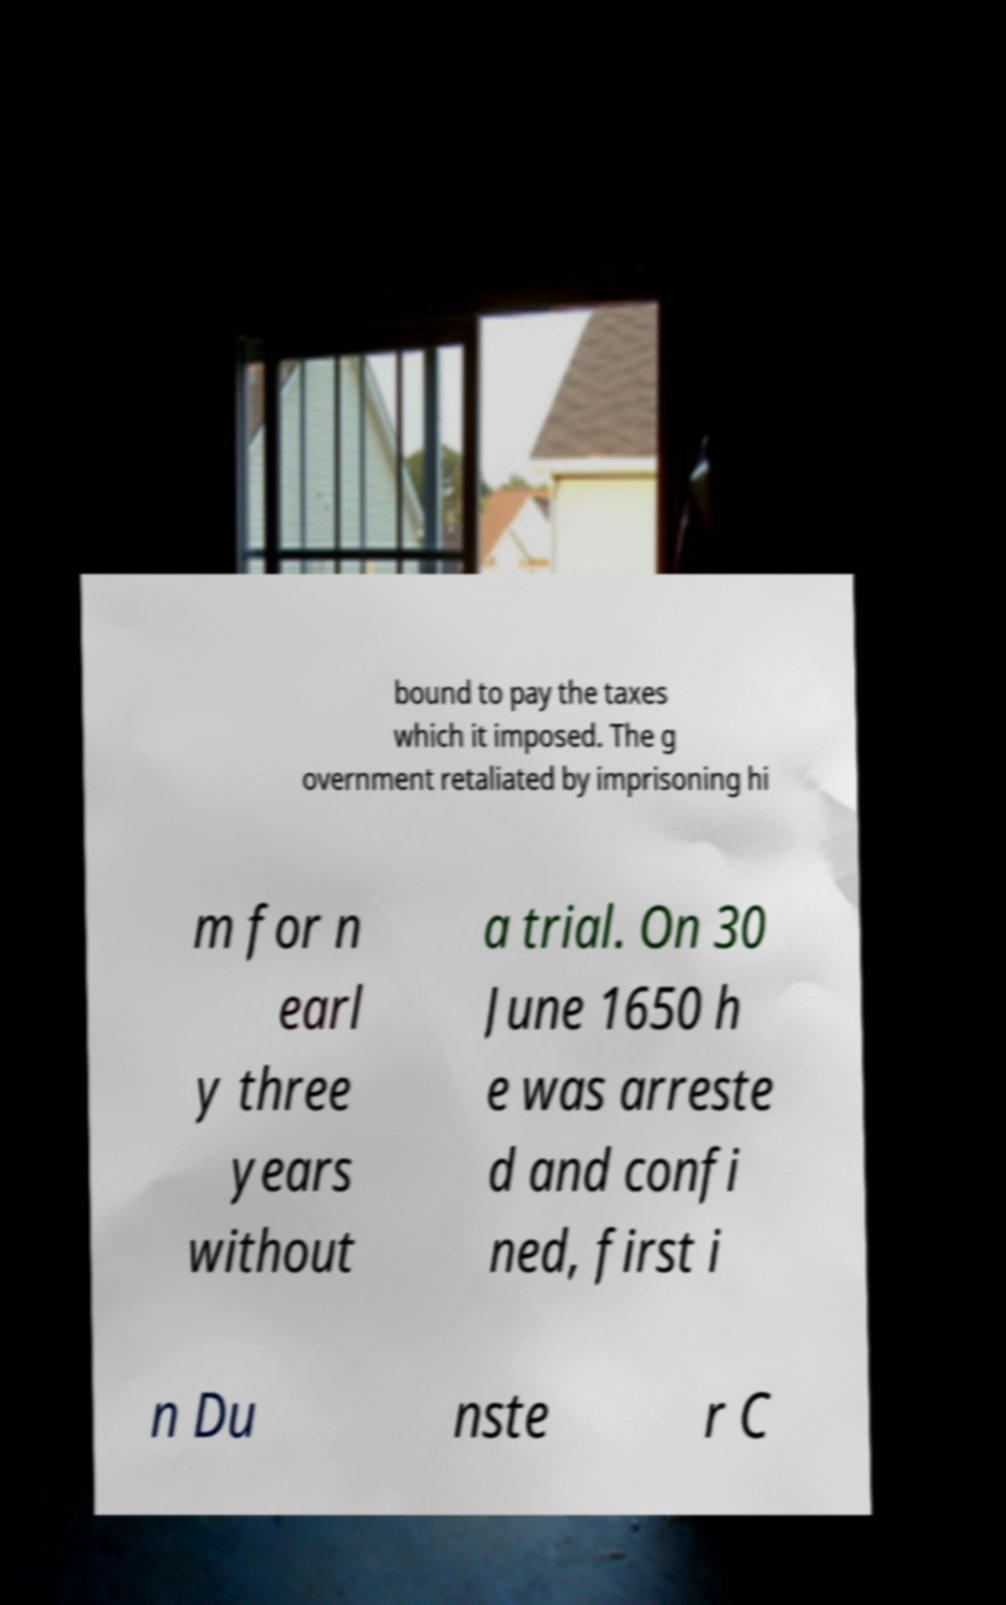Can you read and provide the text displayed in the image?This photo seems to have some interesting text. Can you extract and type it out for me? bound to pay the taxes which it imposed. The g overnment retaliated by imprisoning hi m for n earl y three years without a trial. On 30 June 1650 h e was arreste d and confi ned, first i n Du nste r C 